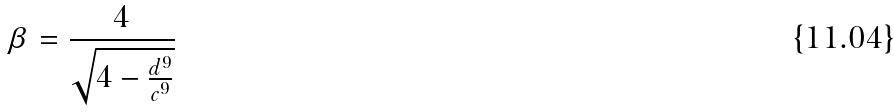Convert formula to latex. <formula><loc_0><loc_0><loc_500><loc_500>\beta = \frac { 4 } { \sqrt { 4 - \frac { d ^ { 9 } } { c ^ { 9 } } } }</formula> 